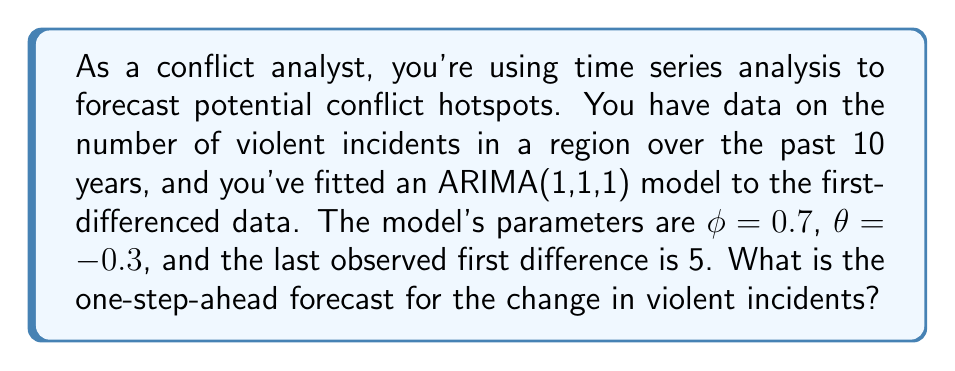Teach me how to tackle this problem. Let's approach this step-by-step:

1) The ARIMA(1,1,1) model for the first-differenced data can be written as:

   $$y_t = c + \phi y_{t-1} + \varepsilon_t - \theta \varepsilon_{t-1}$$

   where $y_t$ represents the first difference at time $t$.

2) For a one-step-ahead forecast, we use the following equation:

   $$\hat{y}_{t+1} = \mathbb{E}(y_{t+1}|y_t, y_{t-1}, ...) = c + \phi y_t - \theta \varepsilon_t$$

3) We're given that $\phi = 0.7$ and $\theta = -0.3$. We're not given a value for $c$, so we'll assume it's 0 (which is often the case in practice).

4) We know $y_t = 5$ (the last observed first difference).

5) We don't know $\varepsilon_t$, but in forecasting, we set unknown future errors to their expected value of 0.

6) Substituting these values into our equation:

   $$\hat{y}_{t+1} = 0 + 0.7(5) - (-0.3)(0) = 3.5$$

Therefore, the one-step-ahead forecast for the change in violent incidents is 3.5.
Answer: 3.5 